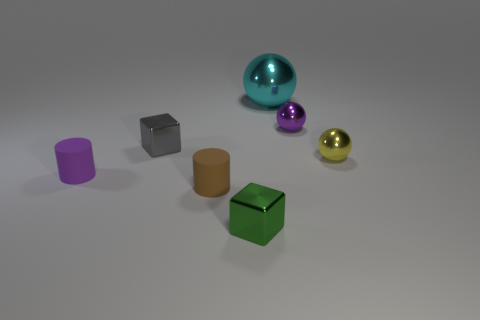Is there a red cylinder made of the same material as the small yellow thing?
Your answer should be compact. No. Is the size of the rubber object that is to the left of the gray metal object the same as the brown matte cylinder?
Provide a short and direct response. Yes. How many yellow objects are tiny cylinders or tiny balls?
Provide a succinct answer. 1. What is the cyan sphere that is on the right side of the green metallic cube made of?
Make the answer very short. Metal. There is a tiny cylinder in front of the small purple matte cylinder; what number of matte cylinders are behind it?
Give a very brief answer. 1. What number of other rubber things have the same shape as the gray thing?
Your response must be concise. 0. What number of small gray metal objects are there?
Offer a very short reply. 1. There is a tiny metal ball that is behind the gray metallic block; what is its color?
Provide a short and direct response. Purple. What is the color of the metallic cube that is in front of the metallic cube that is behind the green object?
Offer a very short reply. Green. What color is the matte object that is the same size as the purple rubber cylinder?
Offer a terse response. Brown. 